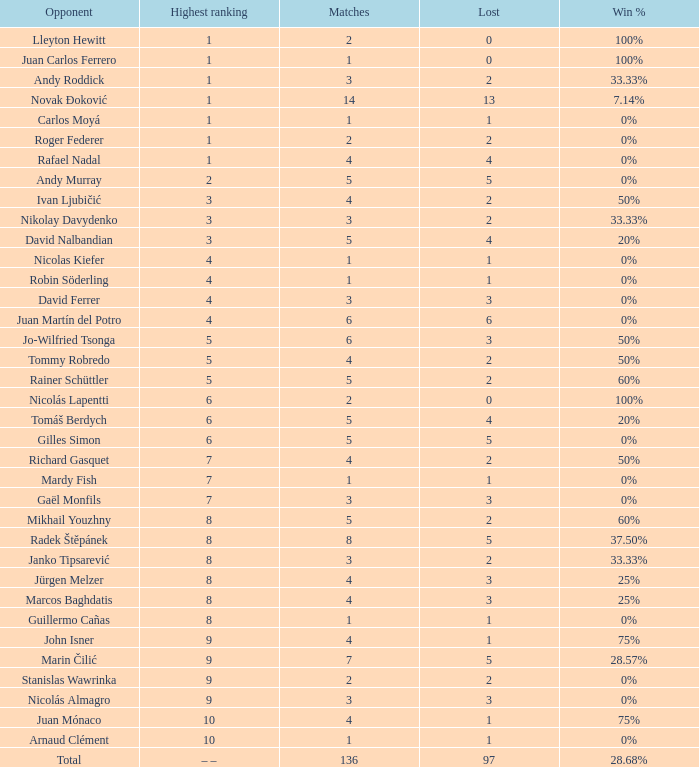What is the total count of lost for the top-ranked – –? 1.0. 